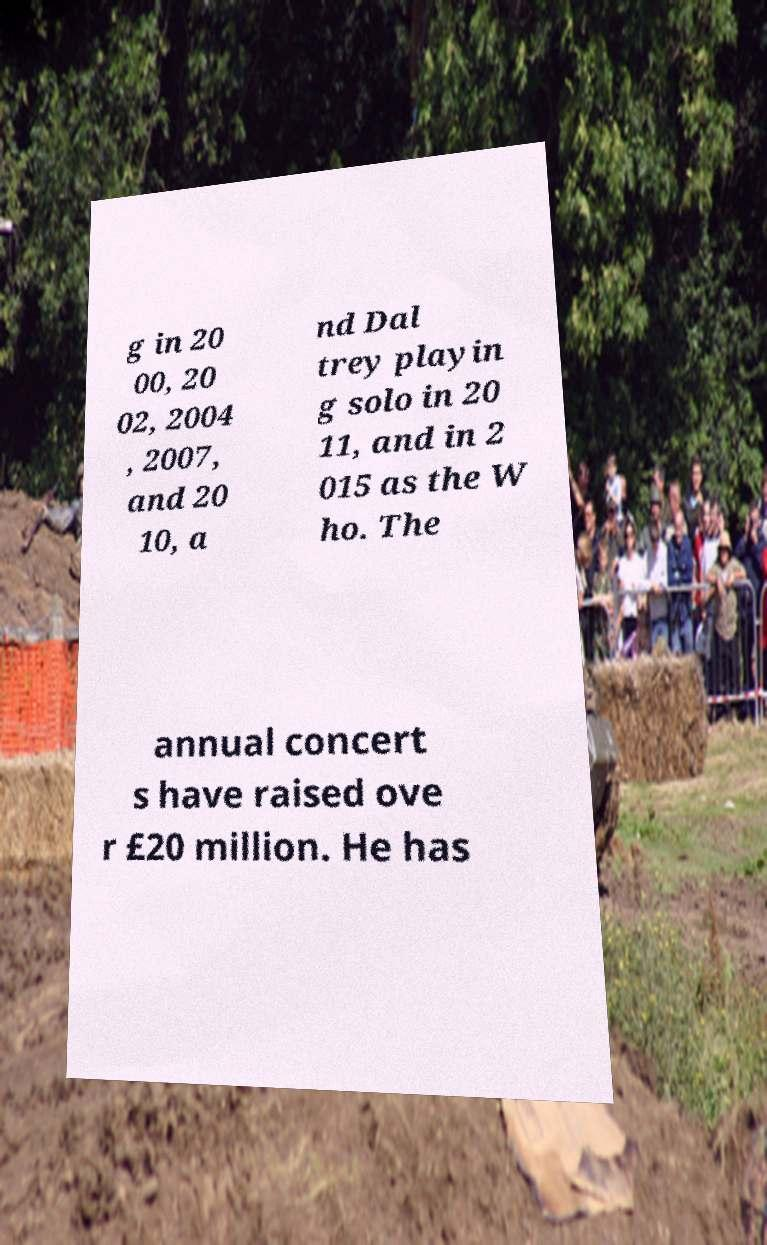What messages or text are displayed in this image? I need them in a readable, typed format. g in 20 00, 20 02, 2004 , 2007, and 20 10, a nd Dal trey playin g solo in 20 11, and in 2 015 as the W ho. The annual concert s have raised ove r £20 million. He has 